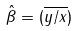Convert formula to latex. <formula><loc_0><loc_0><loc_500><loc_500>\hat { \beta } = ( \overline { y / x } )</formula> 